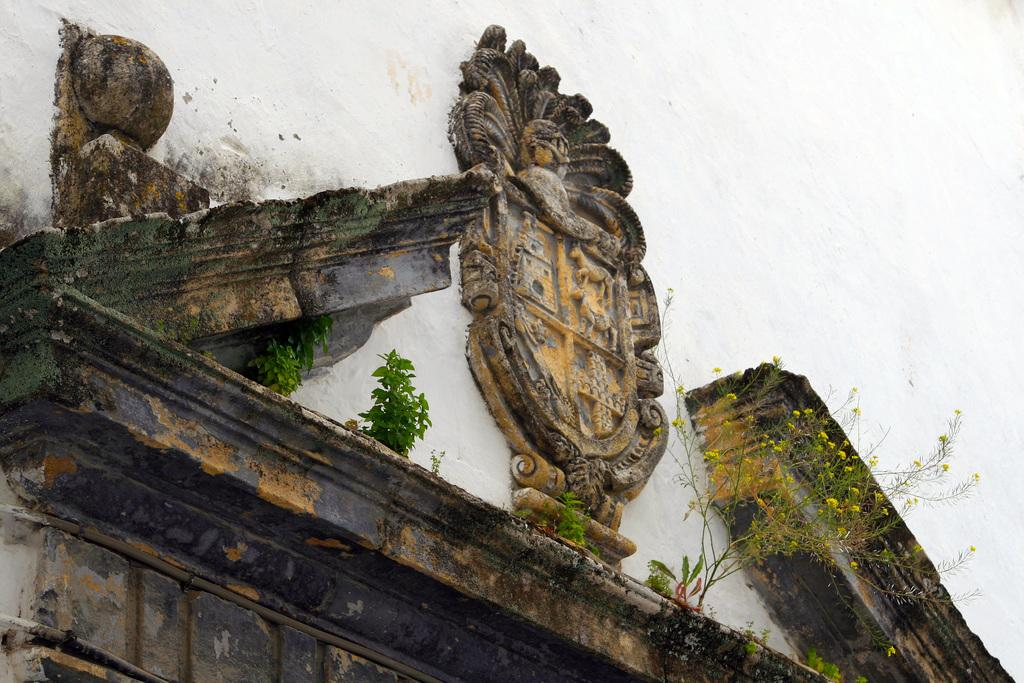What is present on the wall in the image? There are sculptures and plants on the wall in the image. Can you describe the plants on the wall? The plants on the wall are accompanied by algae. What is the overall appearance of the wall in the image? The wall has sculptures, plants, and algae on it. How does the owl compare to the sculptures on the wall in the image? There is no owl present in the image, so it cannot be compared to the sculptures. 